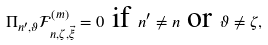<formula> <loc_0><loc_0><loc_500><loc_500>\Pi _ { n ^ { \prime } , \vartheta } \mathcal { F } _ { n , \zeta , \vec { \xi } } ^ { \left ( m \right ) } = 0 \text {\ if } n ^ { \prime } \neq n \text {\ or\ } \vartheta \neq \zeta ,</formula> 